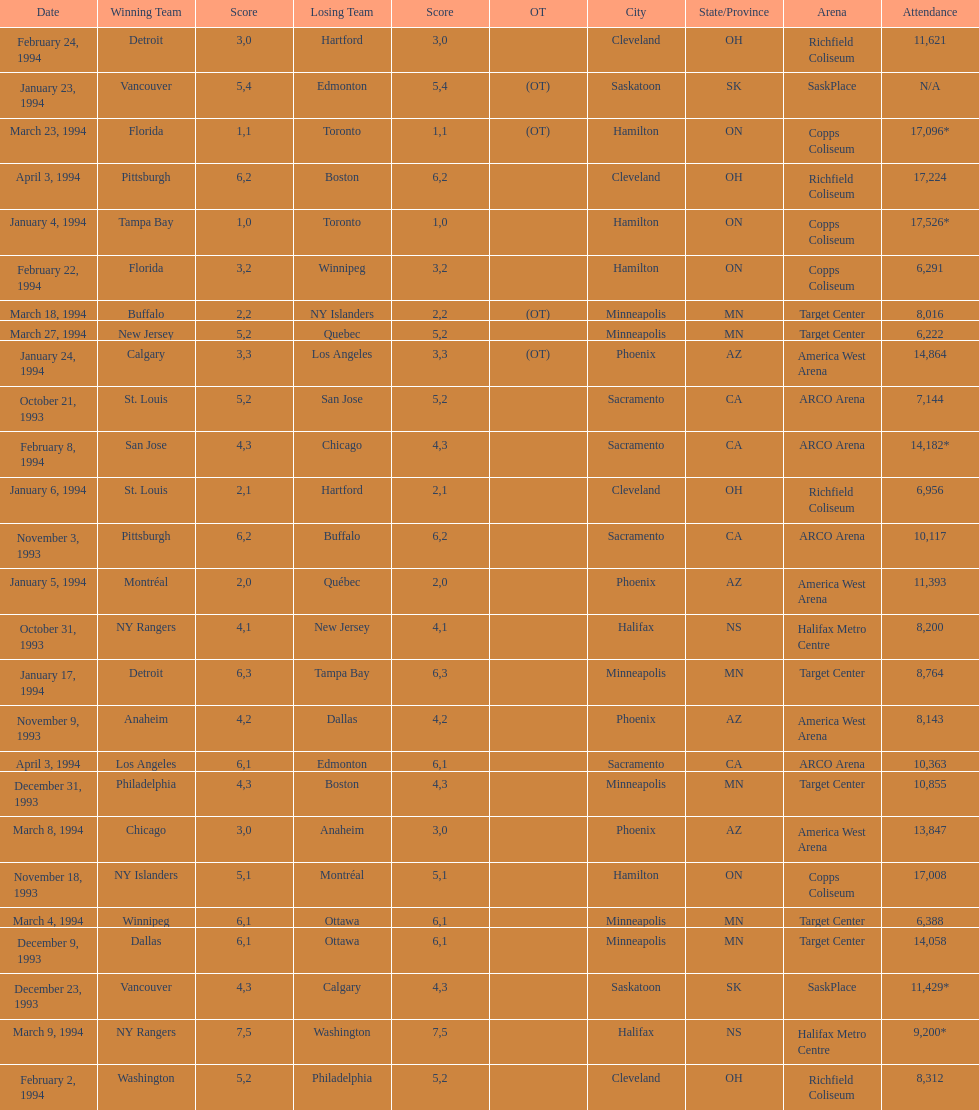Which event had higher attendance, january 24, 1994, or december 23, 1993? January 4, 1994. 